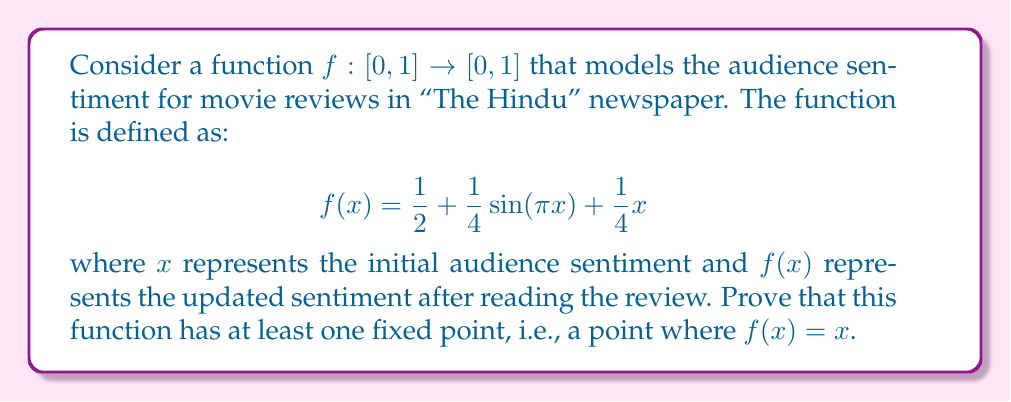Show me your answer to this math problem. To prove the existence of a fixed point for the given function, we can use the Intermediate Value Theorem (IVT). Here's a step-by-step approach:

1) First, define a new function $g(x) = f(x) - x$. A fixed point of $f(x)$ occurs where $g(x) = 0$.

2) Let's examine the behavior of $g(x)$ at the endpoints of the interval $[0, 1]$:

   At $x = 0$:
   $$g(0) = f(0) - 0 = \frac{1}{2} + \frac{1}{4}\sin(0) + 0 - 0 = \frac{1}{2} > 0$$

   At $x = 1$:
   $$g(1) = f(1) - 1 = \frac{1}{2} + \frac{1}{4}\sin(\pi) + \frac{1}{4} - 1 = -\frac{1}{4} < 0$$

3) We've shown that $g(0) > 0$ and $g(1) < 0$.

4) The function $g(x)$ is continuous on $[0, 1]$ because it's composed of continuous functions (constant, sine, and linear functions).

5) By the Intermediate Value Theorem, since $g(x)$ is continuous on $[0, 1]$ and takes values of opposite signs at the endpoints, there must exist a point $c \in (0, 1)$ such that $g(c) = 0$.

6) At this point $c$, we have $g(c) = f(c) - c = 0$, which implies $f(c) = c$.

Therefore, we have proved that there exists at least one fixed point for the function $f(x)$ in the interval $[0, 1]$.

This result aligns with the intuition that there should be a point where the audience sentiment remains unchanged after reading a review in "The Hindu", reflecting a balance between the initial opinion and the influence of the review.
Answer: The function $f(x) = \frac{1}{2} + \frac{1}{4}\sin(\pi x) + \frac{1}{4}x$ has at least one fixed point in the interval $[0, 1]$. 